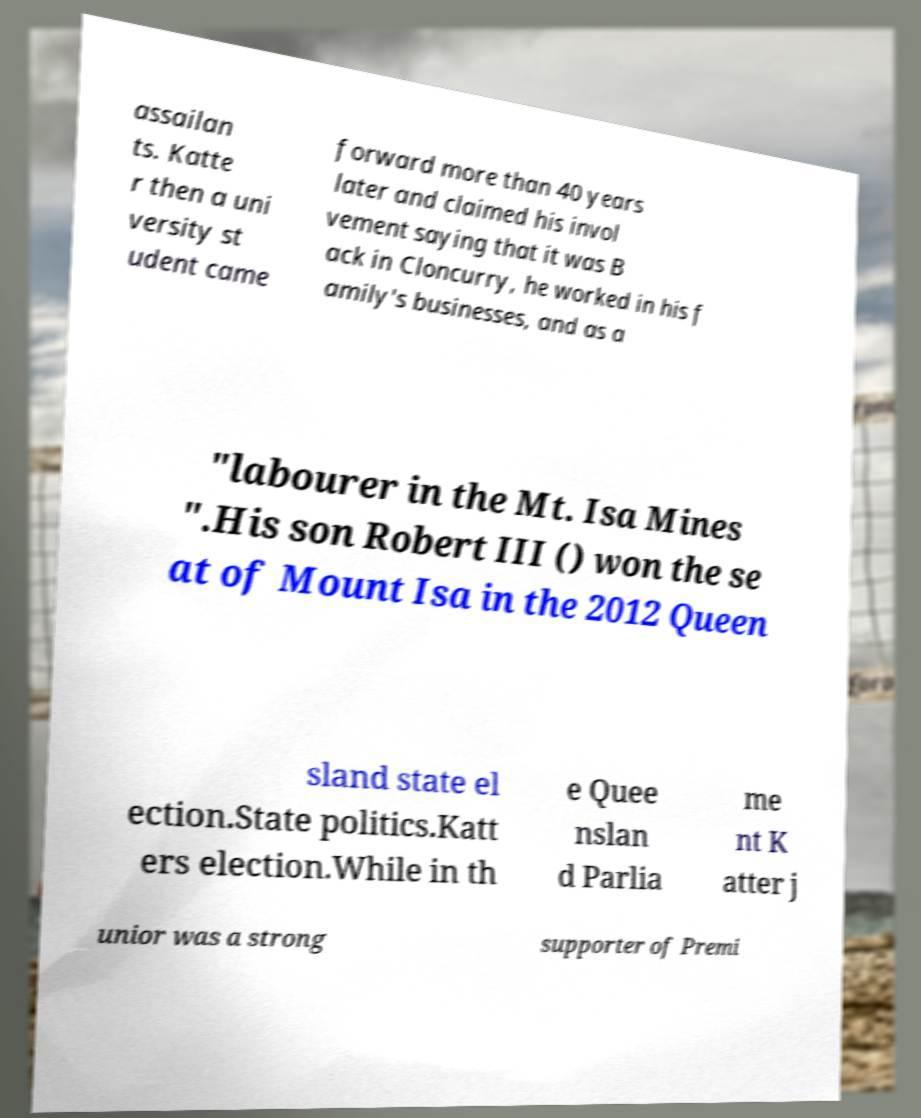Please identify and transcribe the text found in this image. assailan ts. Katte r then a uni versity st udent came forward more than 40 years later and claimed his invol vement saying that it was B ack in Cloncurry, he worked in his f amily's businesses, and as a "labourer in the Mt. Isa Mines ".His son Robert III () won the se at of Mount Isa in the 2012 Queen sland state el ection.State politics.Katt ers election.While in th e Quee nslan d Parlia me nt K atter j unior was a strong supporter of Premi 